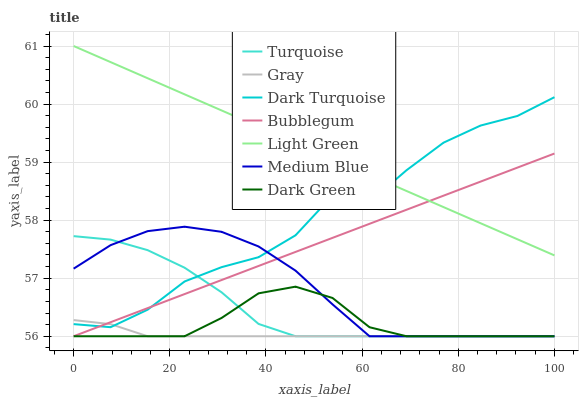Does Gray have the minimum area under the curve?
Answer yes or no. Yes. Does Light Green have the maximum area under the curve?
Answer yes or no. Yes. Does Turquoise have the minimum area under the curve?
Answer yes or no. No. Does Turquoise have the maximum area under the curve?
Answer yes or no. No. Is Bubblegum the smoothest?
Answer yes or no. Yes. Is Dark Turquoise the roughest?
Answer yes or no. Yes. Is Turquoise the smoothest?
Answer yes or no. No. Is Turquoise the roughest?
Answer yes or no. No. Does Dark Turquoise have the lowest value?
Answer yes or no. No. Does Light Green have the highest value?
Answer yes or no. Yes. Does Turquoise have the highest value?
Answer yes or no. No. Is Dark Green less than Dark Turquoise?
Answer yes or no. Yes. Is Dark Turquoise greater than Dark Green?
Answer yes or no. Yes. Does Dark Turquoise intersect Light Green?
Answer yes or no. Yes. Is Dark Turquoise less than Light Green?
Answer yes or no. No. Is Dark Turquoise greater than Light Green?
Answer yes or no. No. Does Dark Green intersect Dark Turquoise?
Answer yes or no. No. 